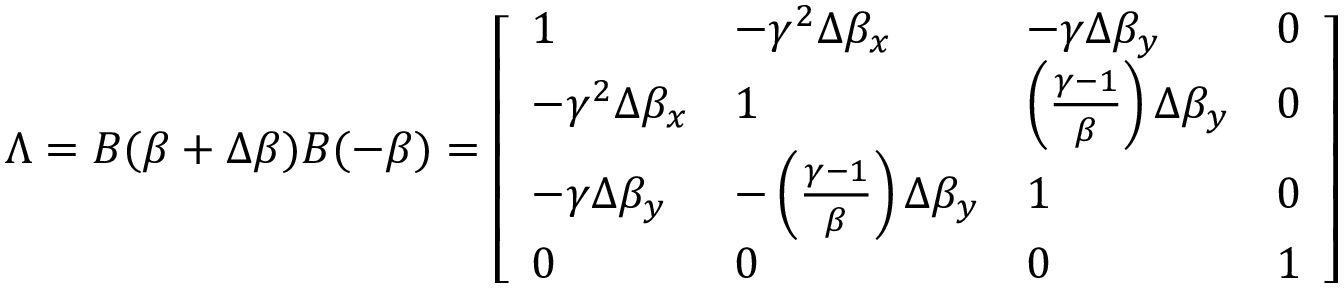Convert formula to latex. <formula><loc_0><loc_0><loc_500><loc_500>\Lambda = B ( { \beta } + \Delta { \beta } ) B ( - { \beta } ) = { \left [ \begin{array} { l l l l } { 1 } & { - \gamma ^ { 2 } \Delta \beta _ { x } } & { - \gamma \Delta \beta _ { y } } & { 0 } \\ { - \gamma ^ { 2 } \Delta \beta _ { x } } & { 1 } & { \left ( { \frac { \gamma - 1 } { \beta } } \right ) \Delta \beta _ { y } } & { 0 } \\ { - \gamma \Delta \beta _ { y } } & { - \left ( { \frac { \gamma - 1 } { \beta } } \right ) \Delta \beta _ { y } } & { 1 } & { 0 } \\ { 0 } & { 0 } & { 0 } & { 1 } \end{array} \right ] }</formula> 